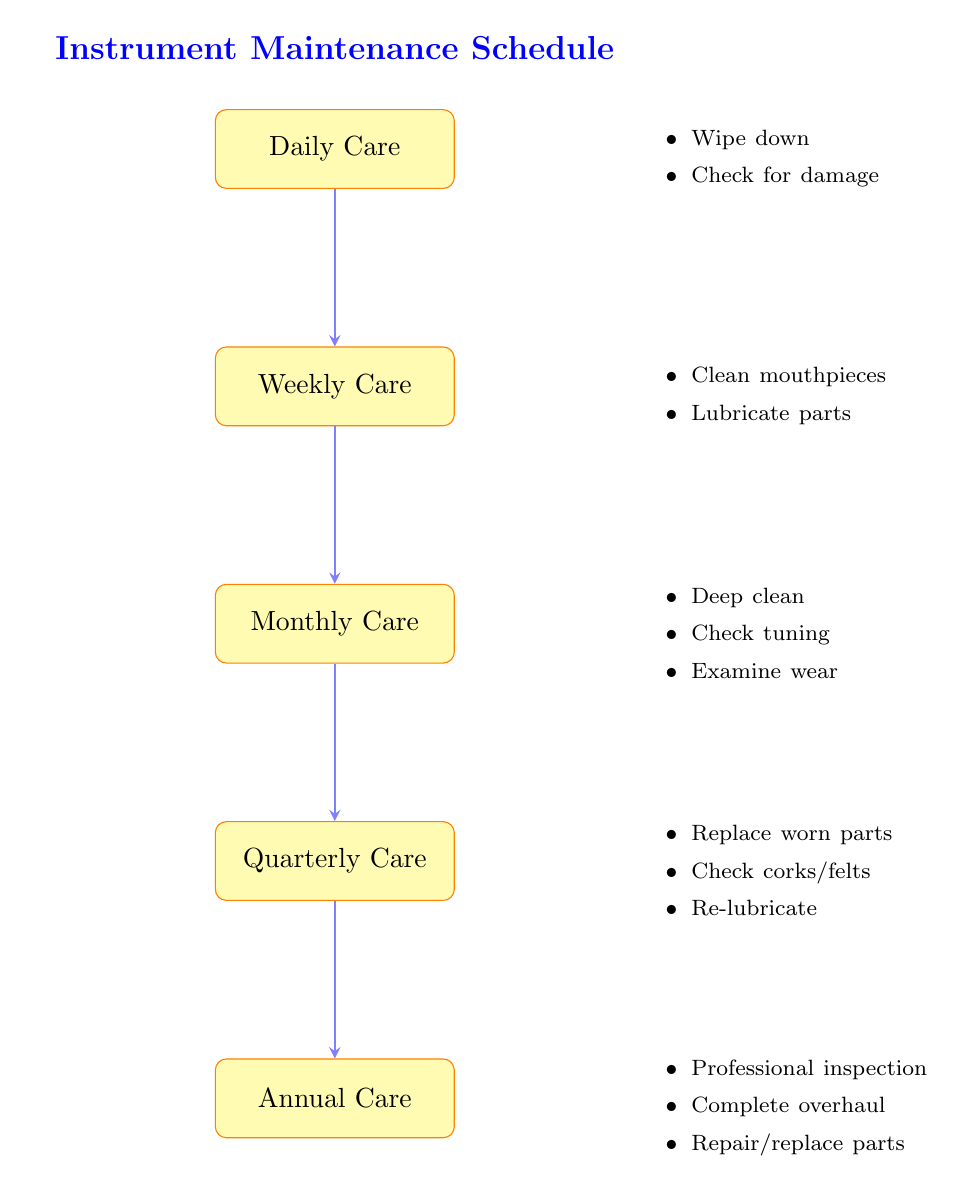What is the first step in the maintenance schedule? The flow chart indicates that the first step is "Daily Care," as it is the topmost node in the diagram.
Answer: Daily Care How many tasks are associated with Quarterly Care? By reviewing the tasks listed under the "Quarterly Care" node, there are three tasks provided in that section.
Answer: 3 What tasks are performed during Annual Care? The "Annual Care" node includes three specific tasks: professional inspection, complete overhaul, and repair or replace parts, which are directly stated in the diagram.
Answer: Professional inspection, complete overhaul, repair or replace parts Which care step comes after Monthly Care? The flow of the diagram shows that "Quarterly Care" follows immediately after "Monthly Care" since there is a direct arrow indicating the sequence.
Answer: Quarterly Care How many total steps are listed in the maintenance schedule? Counting all the individual steps from "Daily Care" to "Annual Care," the flow chart illustrates a total of five maintenance steps or nodes.
Answer: 5 What is the main purpose of the instrument maintenance schedule? The overarching goal of the maintenance schedule, as implied by the title and structure of the flow chart, is to ensure regular care and major repairs are systematically conducted to maintain instrument functionality.
Answer: Regular care to major repairs What type of parts are inspected and potentially replaced in the Quarterly Care step? The tasks listed under "Quarterly Care" specifically mention inspecting and potentially replacing corks or felts as one of the maintenance activities highlighted.
Answer: Corks or felts Which care step involves deep cleaning the instrument? The diagram indicates that "Monthly Care" is the step during which a deep clean using appropriate cleaning solutions is performed.
Answer: Monthly Care 